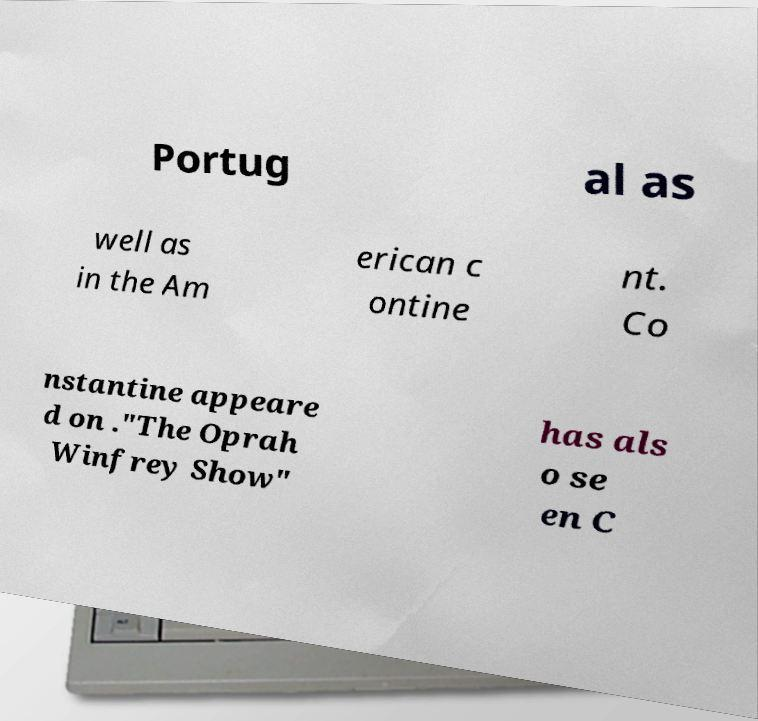Can you read and provide the text displayed in the image?This photo seems to have some interesting text. Can you extract and type it out for me? Portug al as well as in the Am erican c ontine nt. Co nstantine appeare d on ."The Oprah Winfrey Show" has als o se en C 